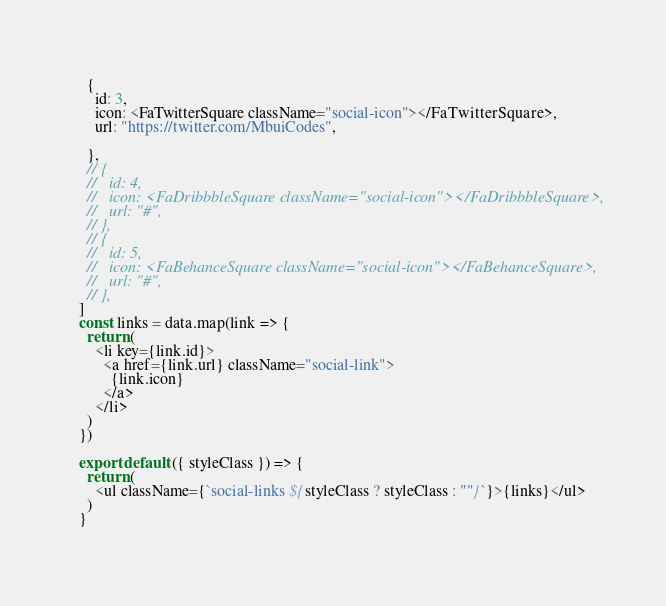Convert code to text. <code><loc_0><loc_0><loc_500><loc_500><_JavaScript_>  {
    id: 3,
    icon: <FaTwitterSquare className="social-icon"></FaTwitterSquare>,
    url: "https://twitter.com/MbuiCodes",
    
  },
  // {
  //   id: 4,
  //   icon: <FaDribbbleSquare className="social-icon"></FaDribbbleSquare>,
  //   url: "#",
  // },
  // {
  //   id: 5,
  //   icon: <FaBehanceSquare className="social-icon"></FaBehanceSquare>,
  //   url: "#",
  // },
]
const links = data.map(link => {
  return (
    <li key={link.id}>
      <a href={link.url} className="social-link">
        {link.icon}
      </a>
    </li>
  )
})

export default ({ styleClass }) => {
  return (
    <ul className={`social-links ${styleClass ? styleClass : ""}`}>{links}</ul>
  )
}
</code> 